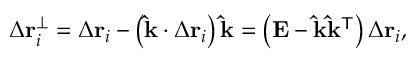Convert formula to latex. <formula><loc_0><loc_0><loc_500><loc_500>\Delta r _ { i } ^ { \perp } = \Delta r _ { i } - \left ( \hat { k } \cdot \Delta r _ { i } \right ) \hat { k } = \left ( E - \hat { k } \hat { k } ^ { T } \right ) \Delta r _ { i } ,</formula> 